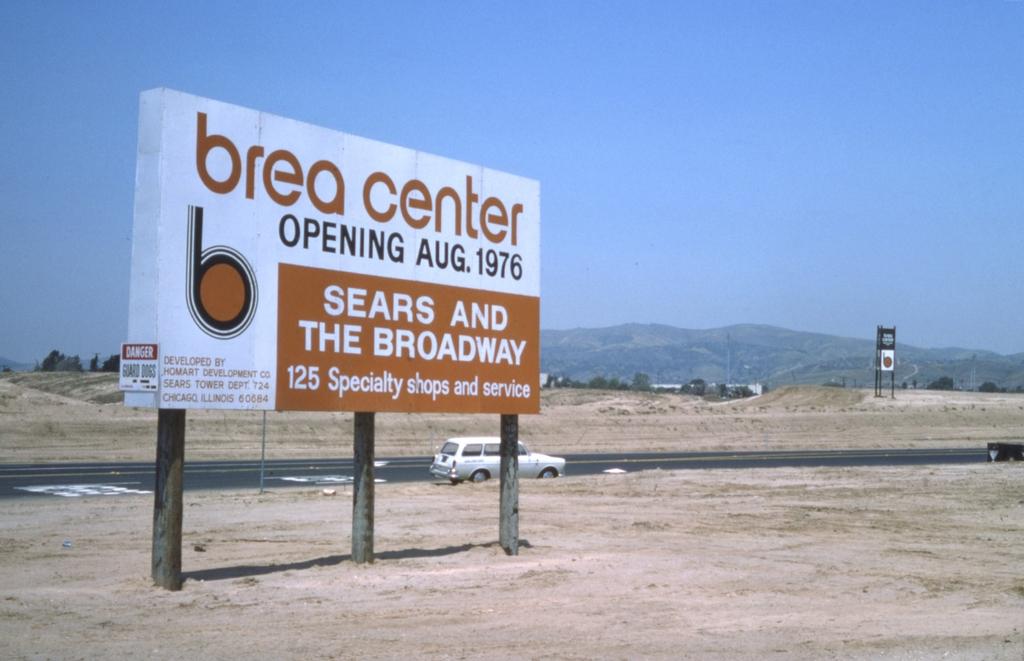When does the brea center open?
Your answer should be very brief. August 1976. Where is this picture taken?
Keep it short and to the point. Brea center. 